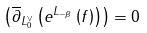Convert formula to latex. <formula><loc_0><loc_0><loc_500><loc_500>\left ( \overline { \partial } _ { L _ { 0 } ^ { \vee } } \left ( e ^ { L _ { - \beta } } \left ( f \right ) \right ) \right ) = 0</formula> 